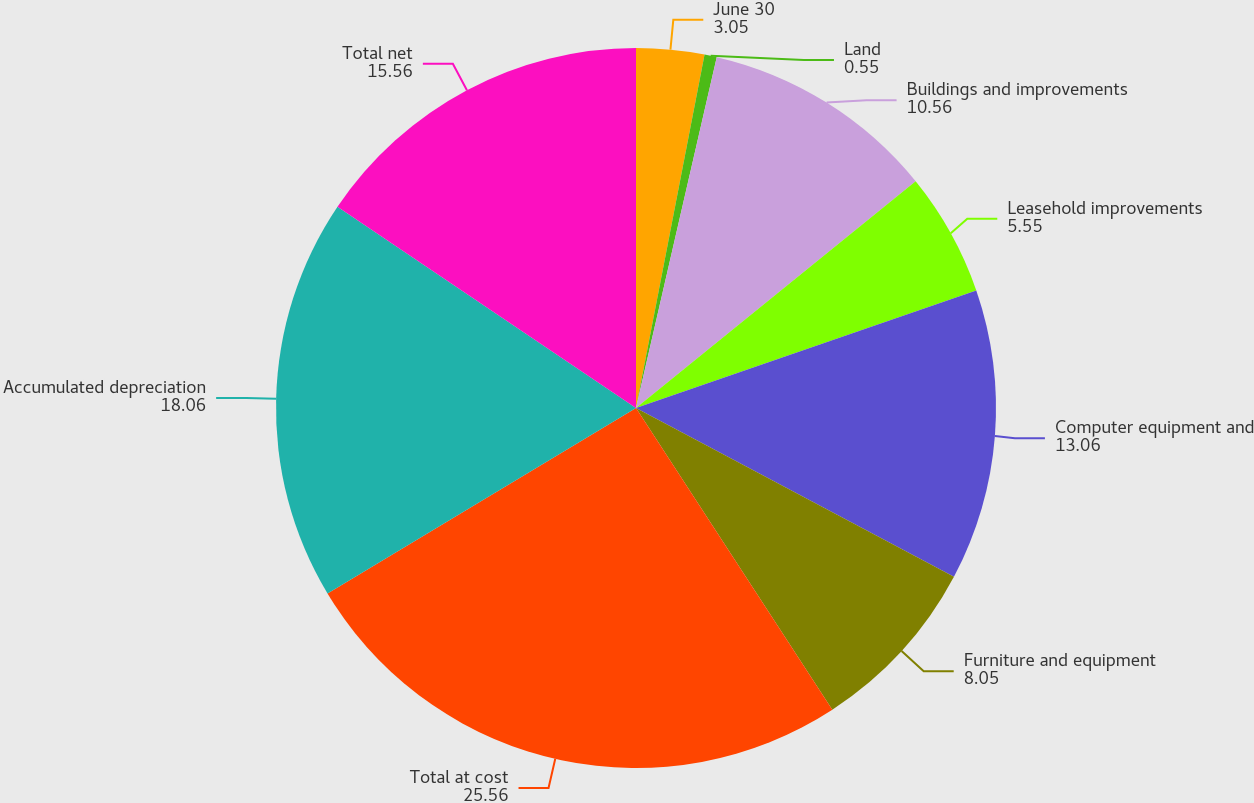<chart> <loc_0><loc_0><loc_500><loc_500><pie_chart><fcel>June 30<fcel>Land<fcel>Buildings and improvements<fcel>Leasehold improvements<fcel>Computer equipment and<fcel>Furniture and equipment<fcel>Total at cost<fcel>Accumulated depreciation<fcel>Total net<nl><fcel>3.05%<fcel>0.55%<fcel>10.56%<fcel>5.55%<fcel>13.06%<fcel>8.05%<fcel>25.56%<fcel>18.06%<fcel>15.56%<nl></chart> 